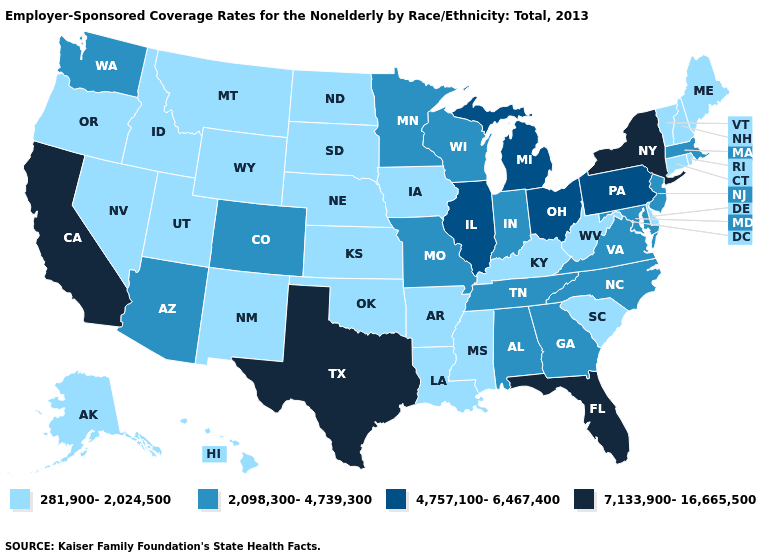Does Iowa have the lowest value in the MidWest?
Give a very brief answer. Yes. What is the lowest value in the USA?
Concise answer only. 281,900-2,024,500. What is the value of Pennsylvania?
Keep it brief. 4,757,100-6,467,400. What is the value of North Carolina?
Give a very brief answer. 2,098,300-4,739,300. Which states have the lowest value in the West?
Answer briefly. Alaska, Hawaii, Idaho, Montana, Nevada, New Mexico, Oregon, Utah, Wyoming. Name the states that have a value in the range 2,098,300-4,739,300?
Write a very short answer. Alabama, Arizona, Colorado, Georgia, Indiana, Maryland, Massachusetts, Minnesota, Missouri, New Jersey, North Carolina, Tennessee, Virginia, Washington, Wisconsin. What is the value of Tennessee?
Quick response, please. 2,098,300-4,739,300. Does Hawaii have the same value as New York?
Quick response, please. No. Does Hawaii have the lowest value in the USA?
Quick response, please. Yes. Which states have the highest value in the USA?
Quick response, please. California, Florida, New York, Texas. Name the states that have a value in the range 4,757,100-6,467,400?
Write a very short answer. Illinois, Michigan, Ohio, Pennsylvania. Name the states that have a value in the range 2,098,300-4,739,300?
Give a very brief answer. Alabama, Arizona, Colorado, Georgia, Indiana, Maryland, Massachusetts, Minnesota, Missouri, New Jersey, North Carolina, Tennessee, Virginia, Washington, Wisconsin. What is the value of Delaware?
Be succinct. 281,900-2,024,500. What is the lowest value in the Northeast?
Keep it brief. 281,900-2,024,500. 